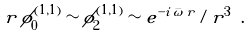<formula> <loc_0><loc_0><loc_500><loc_500>r \, \phi _ { 0 } ^ { ( 1 , 1 ) } \sim \phi _ { 2 } ^ { ( 1 , 1 ) } \sim e ^ { - i \, \bar { \omega } \, r } / r ^ { 3 } \ .</formula> 